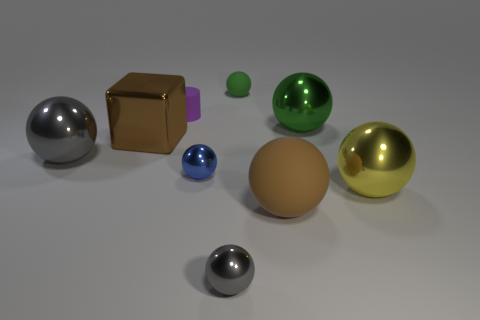Subtract all large metallic spheres. How many spheres are left? 4 Subtract all brown spheres. How many spheres are left? 6 Subtract all green spheres. Subtract all gray cylinders. How many spheres are left? 5 Add 1 large brown metallic cylinders. How many objects exist? 10 Subtract all balls. How many objects are left? 2 Subtract all tiny objects. Subtract all tiny green objects. How many objects are left? 4 Add 6 large matte spheres. How many large matte spheres are left? 7 Add 2 small red metallic spheres. How many small red metallic spheres exist? 2 Subtract 0 red blocks. How many objects are left? 9 